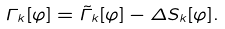<formula> <loc_0><loc_0><loc_500><loc_500>\Gamma _ { k } [ \varphi ] = \tilde { \Gamma } _ { k } [ \varphi ] - \Delta S _ { k } [ \varphi ] .</formula> 